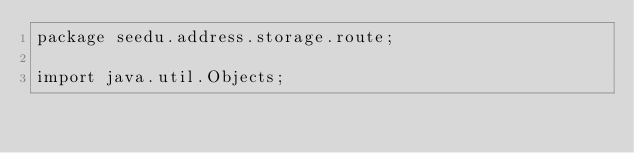Convert code to text. <code><loc_0><loc_0><loc_500><loc_500><_Java_>package seedu.address.storage.route;

import java.util.Objects;
</code> 